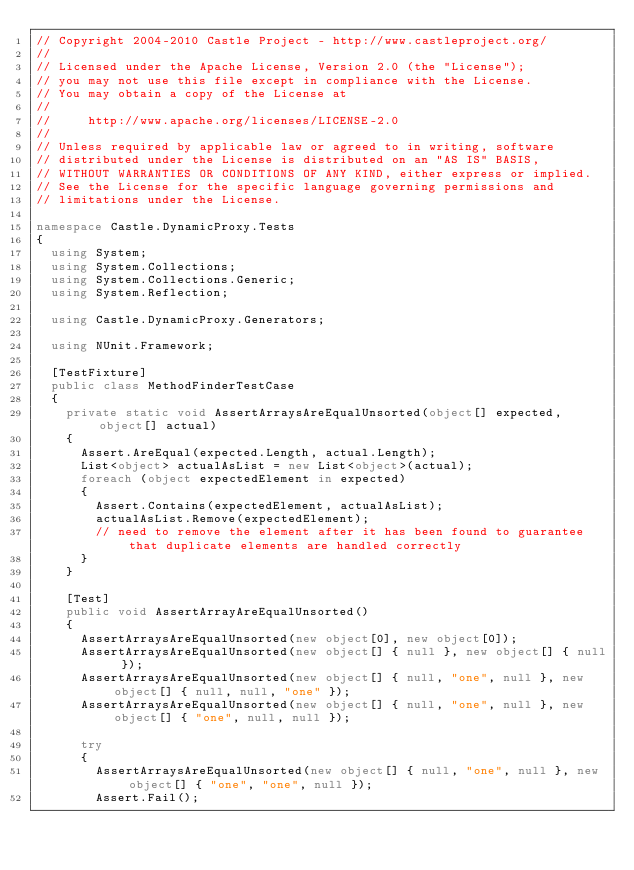Convert code to text. <code><loc_0><loc_0><loc_500><loc_500><_C#_>// Copyright 2004-2010 Castle Project - http://www.castleproject.org/
// 
// Licensed under the Apache License, Version 2.0 (the "License");
// you may not use this file except in compliance with the License.
// You may obtain a copy of the License at
// 
//     http://www.apache.org/licenses/LICENSE-2.0
// 
// Unless required by applicable law or agreed to in writing, software
// distributed under the License is distributed on an "AS IS" BASIS,
// WITHOUT WARRANTIES OR CONDITIONS OF ANY KIND, either express or implied.
// See the License for the specific language governing permissions and
// limitations under the License.

namespace Castle.DynamicProxy.Tests
{
	using System;
	using System.Collections;
	using System.Collections.Generic;
	using System.Reflection;

	using Castle.DynamicProxy.Generators;

	using NUnit.Framework;

	[TestFixture]
	public class MethodFinderTestCase
	{
		private static void AssertArraysAreEqualUnsorted(object[] expected, object[] actual)
		{
			Assert.AreEqual(expected.Length, actual.Length);
			List<object> actualAsList = new List<object>(actual);
			foreach (object expectedElement in expected)
			{
				Assert.Contains(expectedElement, actualAsList);
				actualAsList.Remove(expectedElement);
				// need to remove the element after it has been found to guarantee that duplicate elements are handled correctly
			}
		}

		[Test]
		public void AssertArrayAreEqualUnsorted()
		{
			AssertArraysAreEqualUnsorted(new object[0], new object[0]);
			AssertArraysAreEqualUnsorted(new object[] { null }, new object[] { null });
			AssertArraysAreEqualUnsorted(new object[] { null, "one", null }, new object[] { null, null, "one" });
			AssertArraysAreEqualUnsorted(new object[] { null, "one", null }, new object[] { "one", null, null });

			try
			{
				AssertArraysAreEqualUnsorted(new object[] { null, "one", null }, new object[] { "one", "one", null });
				Assert.Fail();</code> 